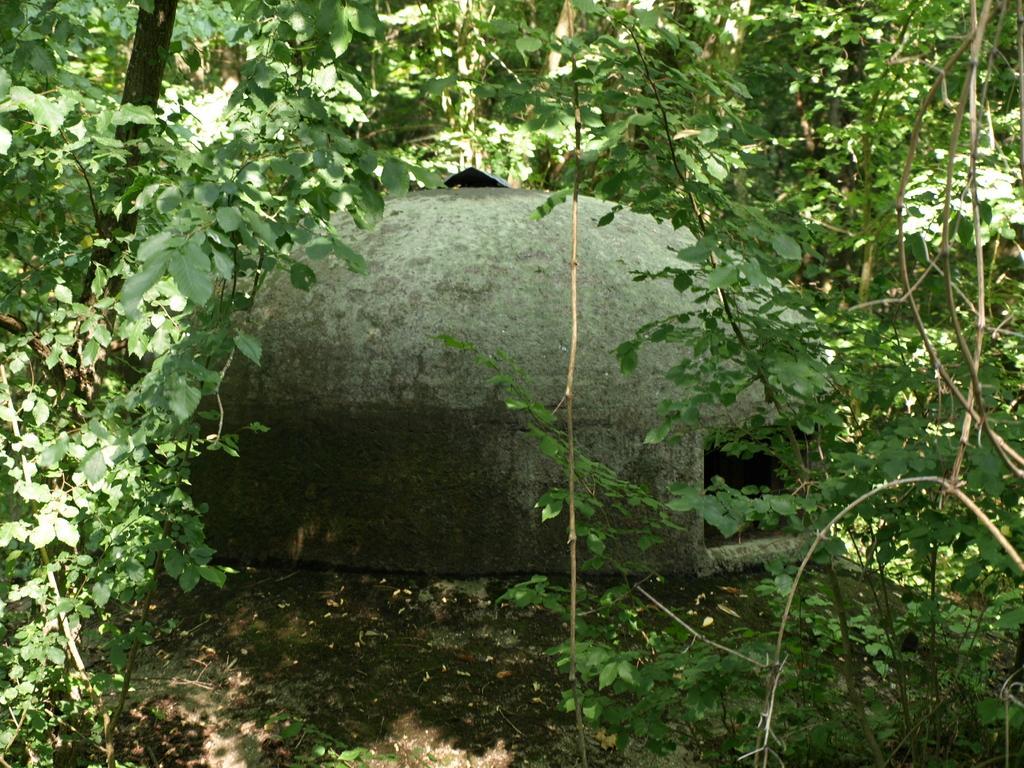How would you summarize this image in a sentence or two? In this image in the center there is one house and in the foreground and background there are some trees, at the bottom there is a walkway. 